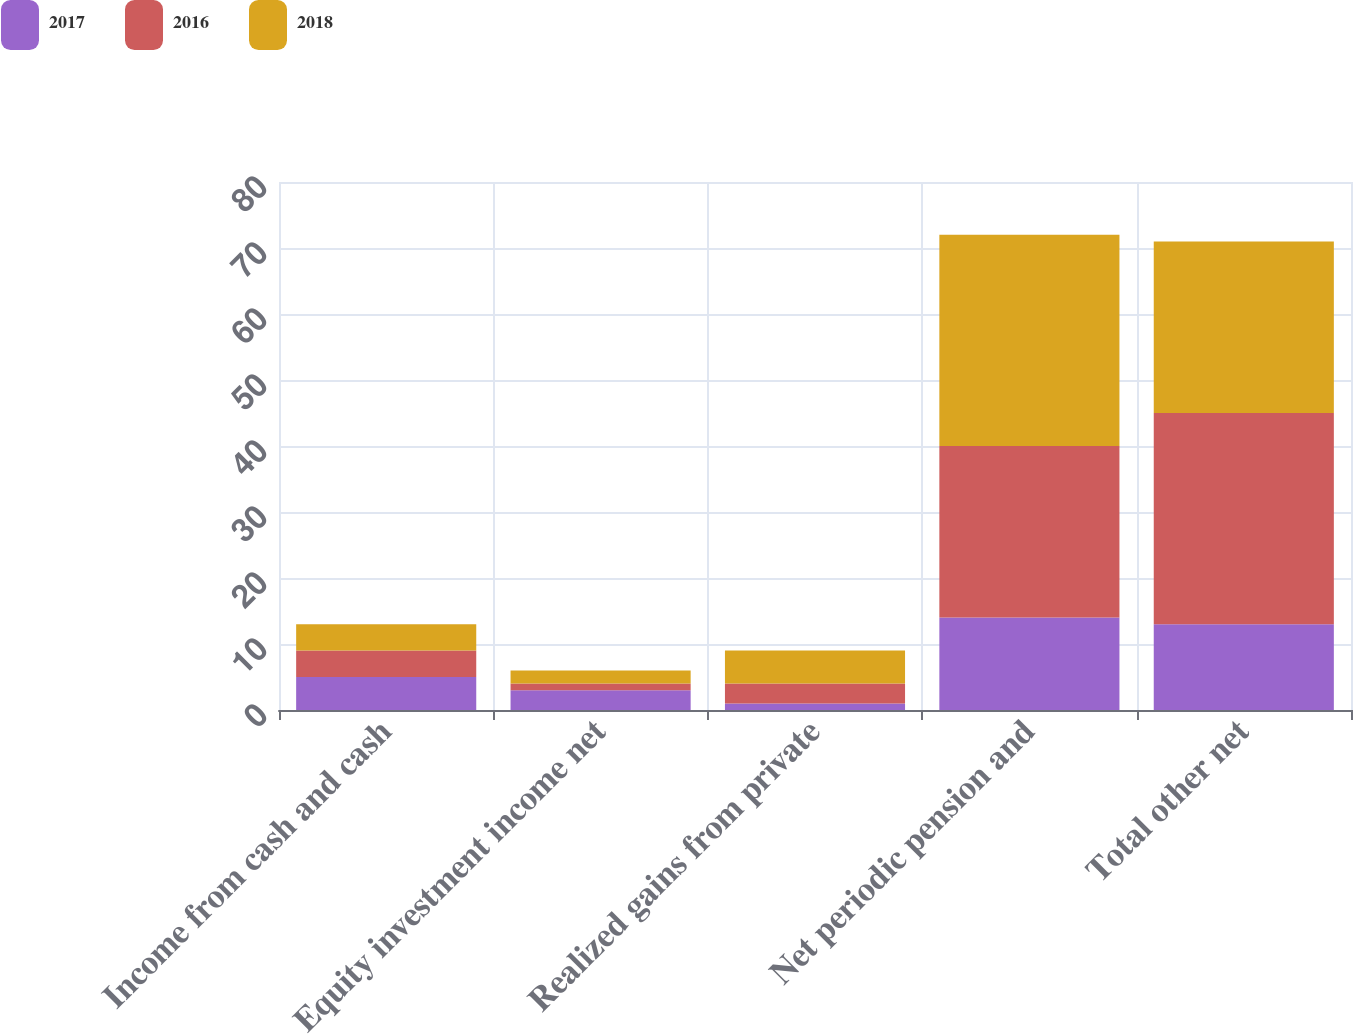<chart> <loc_0><loc_0><loc_500><loc_500><stacked_bar_chart><ecel><fcel>Income from cash and cash<fcel>Equity investment income net<fcel>Realized gains from private<fcel>Net periodic pension and<fcel>Total other net<nl><fcel>2017<fcel>5<fcel>3<fcel>1<fcel>14<fcel>13<nl><fcel>2016<fcel>4<fcel>1<fcel>3<fcel>26<fcel>32<nl><fcel>2018<fcel>4<fcel>2<fcel>5<fcel>32<fcel>26<nl></chart> 